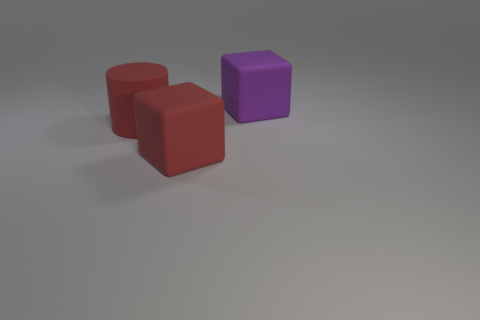Do the cylinder and the large block that is behind the red cylinder have the same color?
Provide a succinct answer. No. There is a rubber object that is both right of the large matte cylinder and in front of the large purple rubber object; what is its shape?
Offer a very short reply. Cube. What material is the purple object that is behind the large rubber cube that is in front of the big matte block to the right of the red cube?
Offer a very short reply. Rubber. Is the number of large red rubber cylinders that are behind the cylinder greater than the number of large purple rubber cubes that are behind the big purple rubber block?
Give a very brief answer. No. How many large red things are made of the same material as the large red cube?
Your response must be concise. 1. Do the purple object behind the big matte cylinder and the red thing that is to the right of the cylinder have the same shape?
Your answer should be very brief. Yes. The matte cylinder in front of the large purple block is what color?
Offer a very short reply. Red. Is there another rubber object of the same shape as the purple rubber thing?
Your response must be concise. Yes. What is the material of the purple cube?
Provide a short and direct response. Rubber. There is a matte thing that is both right of the cylinder and left of the large purple object; how big is it?
Keep it short and to the point. Large. 